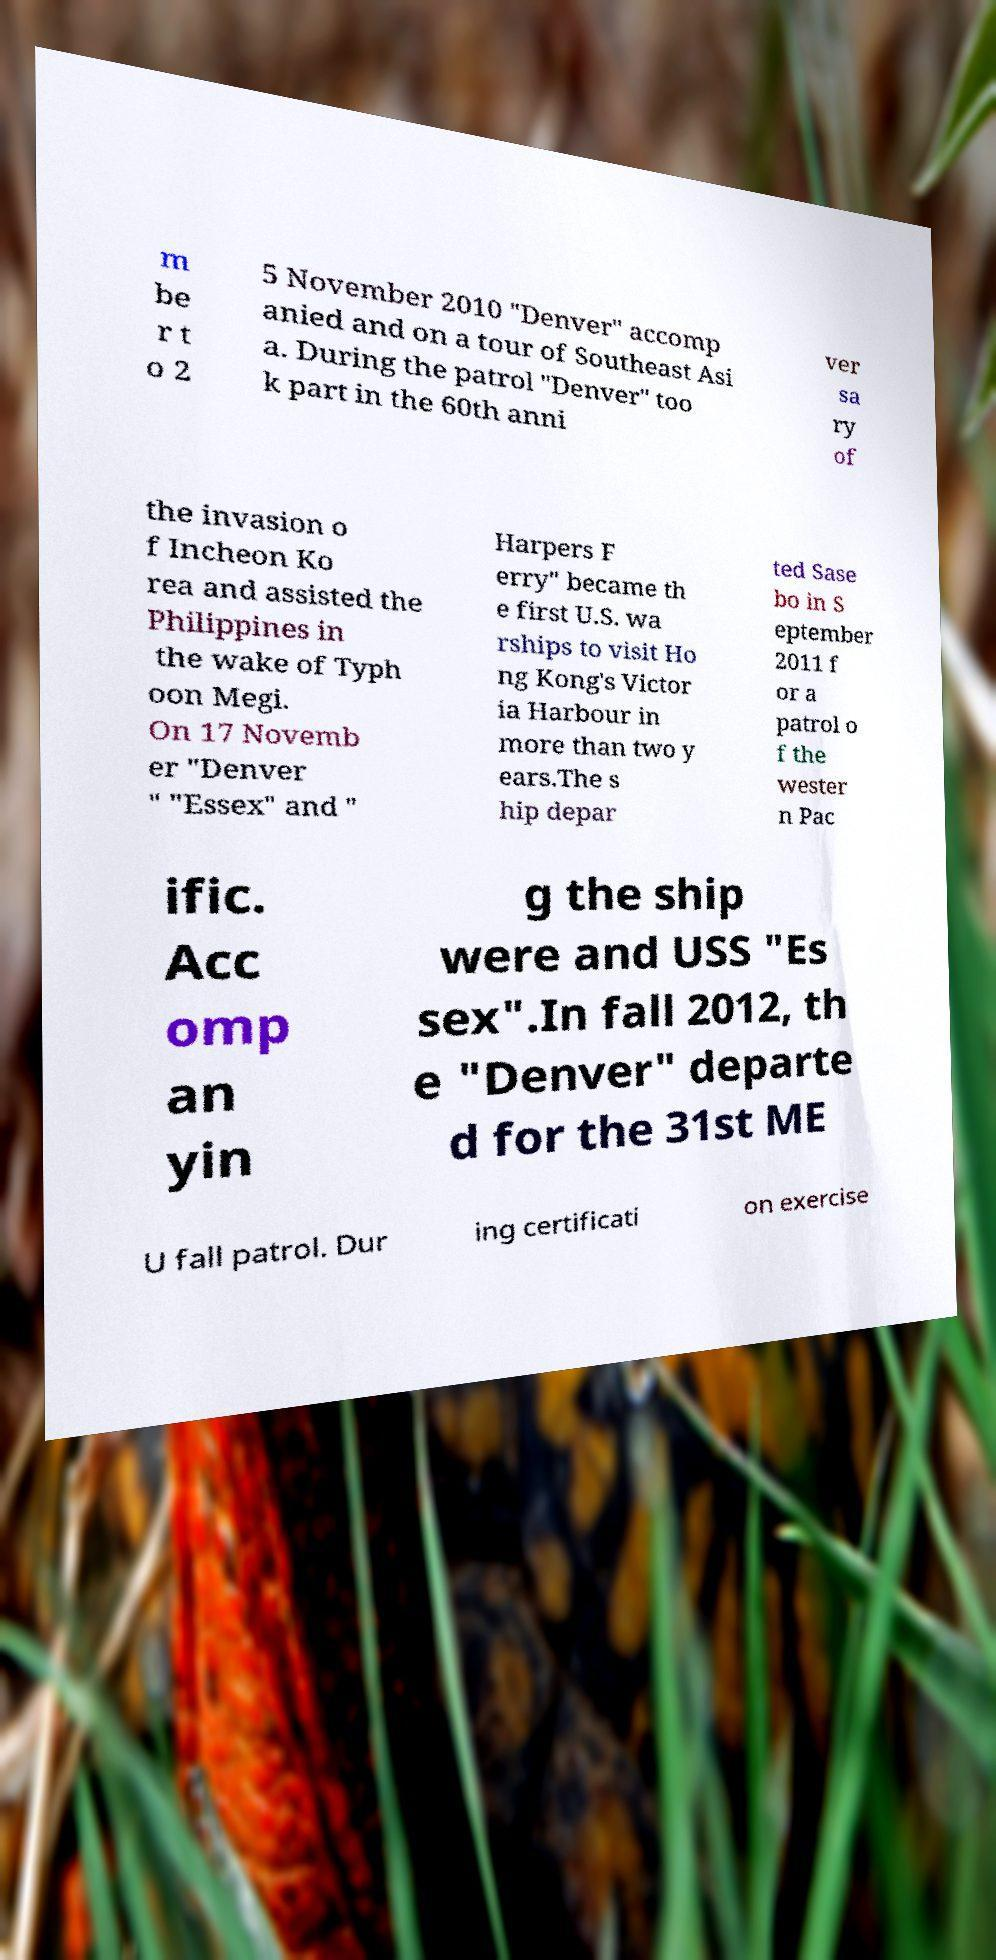For documentation purposes, I need the text within this image transcribed. Could you provide that? m be r t o 2 5 November 2010 "Denver" accomp anied and on a tour of Southeast Asi a. During the patrol "Denver" too k part in the 60th anni ver sa ry of the invasion o f Incheon Ko rea and assisted the Philippines in the wake of Typh oon Megi. On 17 Novemb er "Denver " "Essex" and " Harpers F erry" became th e first U.S. wa rships to visit Ho ng Kong's Victor ia Harbour in more than two y ears.The s hip depar ted Sase bo in S eptember 2011 f or a patrol o f the wester n Pac ific. Acc omp an yin g the ship were and USS "Es sex".In fall 2012, th e "Denver" departe d for the 31st ME U fall patrol. Dur ing certificati on exercise 